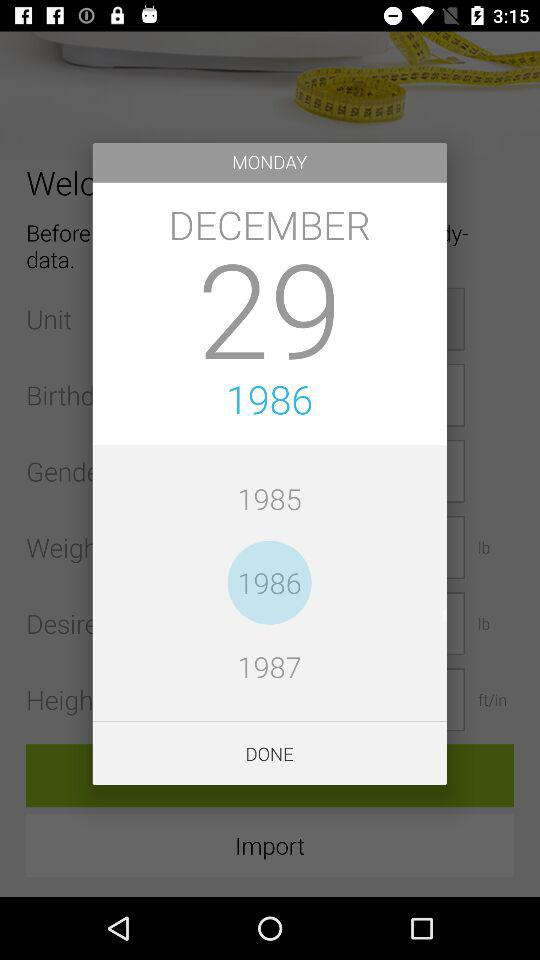Which year is selected? The selected year is 1986. 